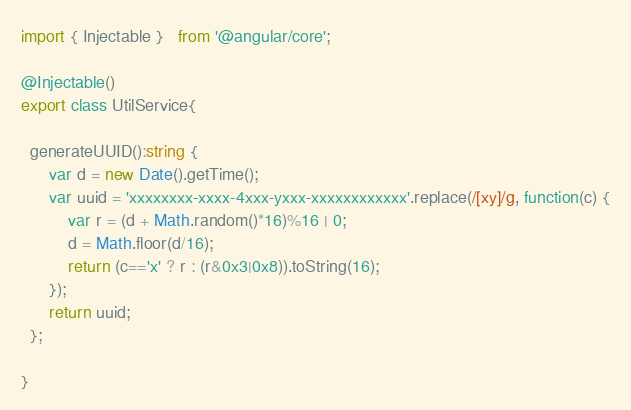<code> <loc_0><loc_0><loc_500><loc_500><_TypeScript_>import { Injectable }   from '@angular/core';

@Injectable()
export class UtilService{

  generateUUID():string {
      var d = new Date().getTime();
      var uuid = 'xxxxxxxx-xxxx-4xxx-yxxx-xxxxxxxxxxxx'.replace(/[xy]/g, function(c) {
          var r = (d + Math.random()*16)%16 | 0;
          d = Math.floor(d/16);
          return (c=='x' ? r : (r&0x3|0x8)).toString(16);
      });
      return uuid;
  };

}
</code> 